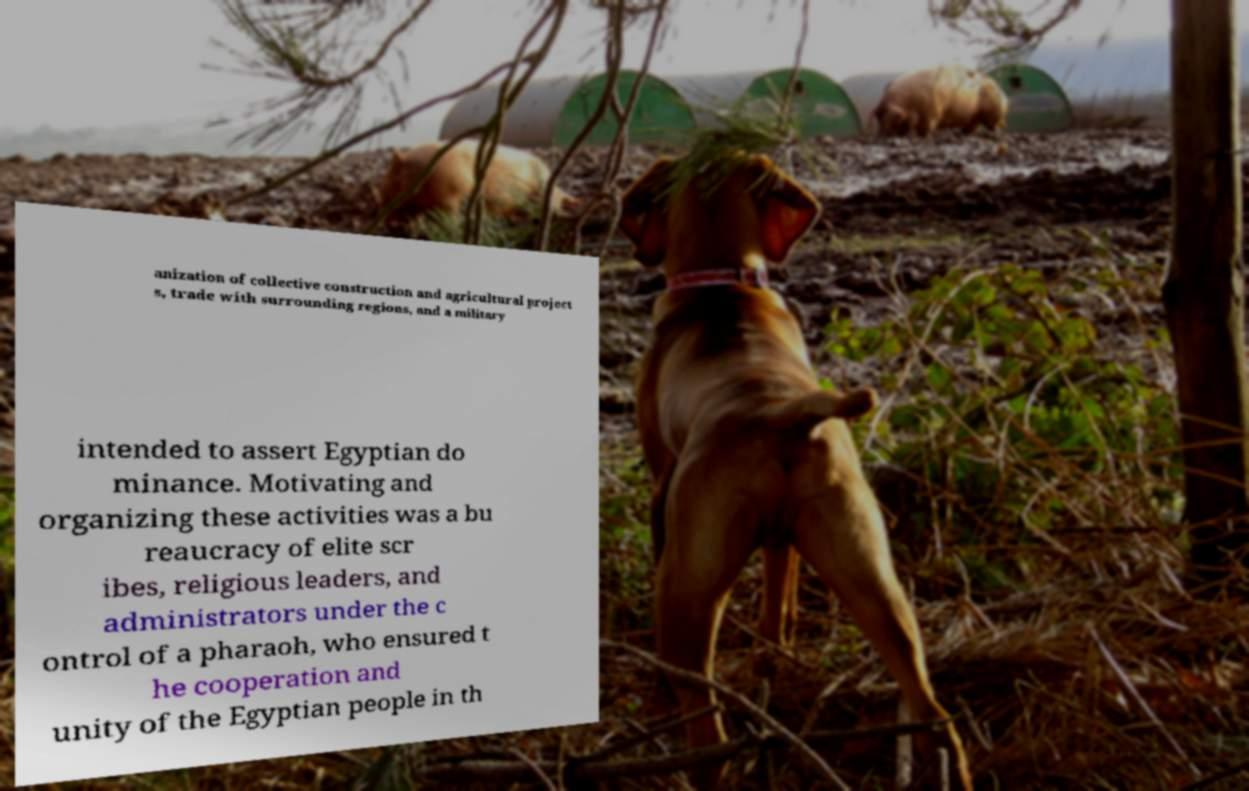What messages or text are displayed in this image? I need them in a readable, typed format. anization of collective construction and agricultural project s, trade with surrounding regions, and a military intended to assert Egyptian do minance. Motivating and organizing these activities was a bu reaucracy of elite scr ibes, religious leaders, and administrators under the c ontrol of a pharaoh, who ensured t he cooperation and unity of the Egyptian people in th 